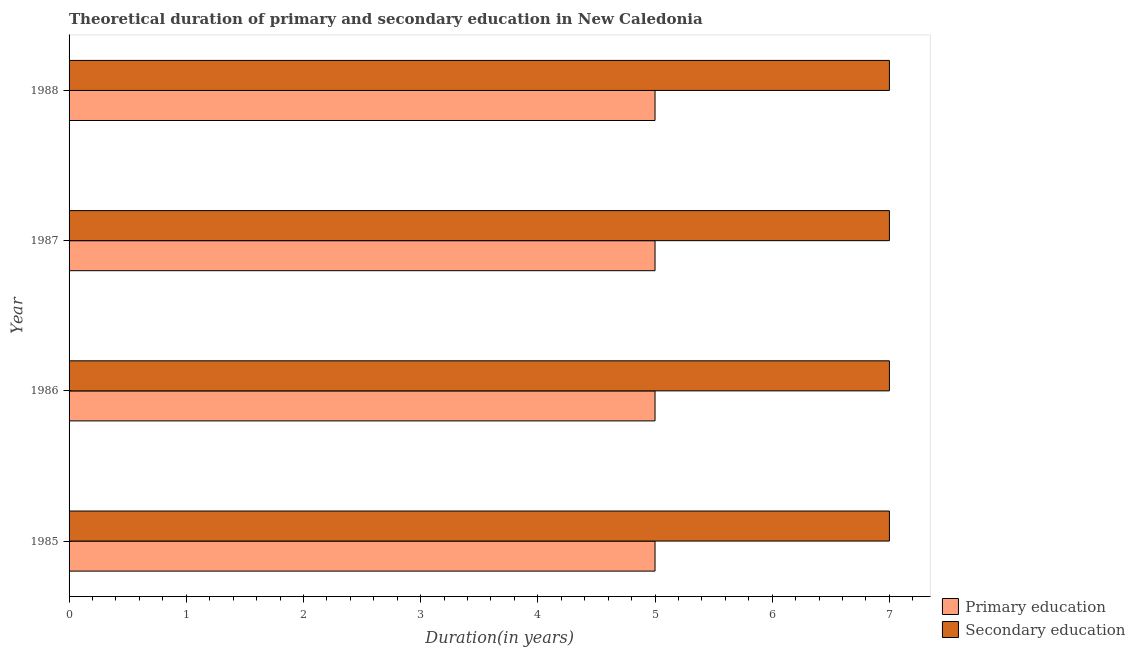How many groups of bars are there?
Ensure brevity in your answer.  4. Are the number of bars per tick equal to the number of legend labels?
Ensure brevity in your answer.  Yes. How many bars are there on the 1st tick from the top?
Offer a very short reply. 2. What is the duration of primary education in 1985?
Your answer should be compact. 5. Across all years, what is the maximum duration of primary education?
Your answer should be very brief. 5. Across all years, what is the minimum duration of secondary education?
Your answer should be compact. 7. What is the total duration of primary education in the graph?
Provide a succinct answer. 20. What is the difference between the duration of primary education in 1986 and that in 1987?
Offer a terse response. 0. What is the difference between the duration of primary education in 1985 and the duration of secondary education in 1986?
Your response must be concise. -2. In the year 1988, what is the difference between the duration of primary education and duration of secondary education?
Provide a succinct answer. -2. In how many years, is the duration of primary education greater than 1.4 years?
Keep it short and to the point. 4. Is the duration of secondary education in 1985 less than that in 1986?
Your answer should be compact. No. What does the 1st bar from the top in 1987 represents?
Your answer should be very brief. Secondary education. What does the 2nd bar from the bottom in 1987 represents?
Keep it short and to the point. Secondary education. How many bars are there?
Offer a very short reply. 8. Are the values on the major ticks of X-axis written in scientific E-notation?
Provide a short and direct response. No. Does the graph contain any zero values?
Keep it short and to the point. No. Does the graph contain grids?
Your response must be concise. No. Where does the legend appear in the graph?
Ensure brevity in your answer.  Bottom right. How many legend labels are there?
Make the answer very short. 2. How are the legend labels stacked?
Make the answer very short. Vertical. What is the title of the graph?
Ensure brevity in your answer.  Theoretical duration of primary and secondary education in New Caledonia. What is the label or title of the X-axis?
Keep it short and to the point. Duration(in years). What is the label or title of the Y-axis?
Give a very brief answer. Year. What is the Duration(in years) of Primary education in 1985?
Make the answer very short. 5. What is the Duration(in years) in Secondary education in 1985?
Provide a succinct answer. 7. What is the Duration(in years) in Primary education in 1986?
Offer a terse response. 5. What is the Duration(in years) of Primary education in 1987?
Keep it short and to the point. 5. What is the Duration(in years) of Secondary education in 1987?
Offer a terse response. 7. Across all years, what is the maximum Duration(in years) in Primary education?
Offer a terse response. 5. Across all years, what is the maximum Duration(in years) in Secondary education?
Your response must be concise. 7. Across all years, what is the minimum Duration(in years) in Primary education?
Give a very brief answer. 5. What is the difference between the Duration(in years) of Primary education in 1985 and that in 1987?
Keep it short and to the point. 0. What is the difference between the Duration(in years) in Primary education in 1985 and that in 1988?
Make the answer very short. 0. What is the difference between the Duration(in years) in Primary education in 1987 and that in 1988?
Ensure brevity in your answer.  0. What is the difference between the Duration(in years) of Primary education in 1985 and the Duration(in years) of Secondary education in 1986?
Give a very brief answer. -2. What is the difference between the Duration(in years) in Primary education in 1985 and the Duration(in years) in Secondary education in 1987?
Give a very brief answer. -2. What is the difference between the Duration(in years) in Primary education in 1985 and the Duration(in years) in Secondary education in 1988?
Offer a terse response. -2. What is the average Duration(in years) in Secondary education per year?
Your response must be concise. 7. In the year 1985, what is the difference between the Duration(in years) in Primary education and Duration(in years) in Secondary education?
Give a very brief answer. -2. In the year 1987, what is the difference between the Duration(in years) in Primary education and Duration(in years) in Secondary education?
Keep it short and to the point. -2. What is the ratio of the Duration(in years) of Primary education in 1985 to that in 1986?
Make the answer very short. 1. What is the ratio of the Duration(in years) of Secondary education in 1985 to that in 1986?
Provide a short and direct response. 1. What is the ratio of the Duration(in years) of Primary education in 1985 to that in 1987?
Your response must be concise. 1. What is the ratio of the Duration(in years) of Secondary education in 1985 to that in 1987?
Your answer should be very brief. 1. What is the ratio of the Duration(in years) in Primary education in 1986 to that in 1987?
Your response must be concise. 1. What is the ratio of the Duration(in years) of Secondary education in 1986 to that in 1988?
Ensure brevity in your answer.  1. What is the difference between the highest and the second highest Duration(in years) in Secondary education?
Your response must be concise. 0. What is the difference between the highest and the lowest Duration(in years) in Secondary education?
Your response must be concise. 0. 